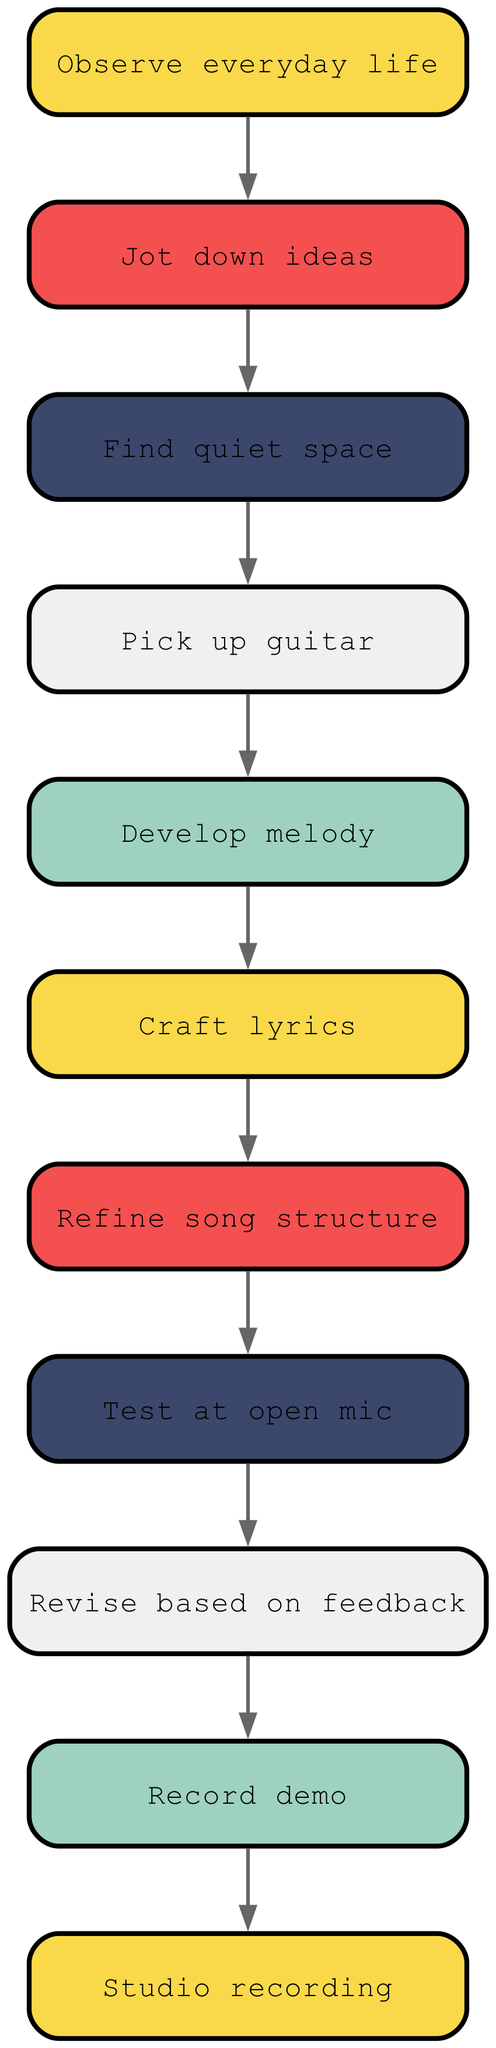What is the first step in the songwriting process? The diagram indicates that the first step in John Prine's songwriting process is to "Observe everyday life." This is the initial node before any other actions are taken.
Answer: Observe everyday life How many nodes are in the diagram? By counting all the unique processes involved in the diagram, we find there are 11 distinct nodes representing different steps in the songwriting process.
Answer: 11 What is the last step before "Studio recording"? The edge connecting "Record demo" to "Studio recording" shows that the last step before asserting a studio recording is the creation of a demo.
Answer: Record demo What is the relationship between "Revise based on feedback" and "Test at open mic"? The diagram shows a directed edge from "Test at open mic" leading to "Revise based on feedback," indicating that feedback gathered from testing the song live is used for revising the song accordingly.
Answer: Revise based on feedback Which step follows "Craft lyrics"? The flow directed from "Craft lyrics" leads to "Refine song structure," meaning this step occurs next in the process after writing the lyrics.
Answer: Refine song structure Name two steps that occur after finding a quiet space. After "Find quiet space," the diagram shows that the next steps are "Pick up guitar" and subsequently "Develop melody." Therefore, both of these steps come next in the process.
Answer: Pick up guitar, Develop melody What is the step immediately preceding "Record demo"? The directed edge from "Revise based on feedback" clearly indicates that this is the immediate step before moving on to the "Record demo."
Answer: Revise based on feedback Is there any step that occurs before "Develop melody"? If so, name it. Yes, according to the directed flow, "Pick up guitar" occurs immediately before "Develop melody," serving as a precursor to creating the melody itself.
Answer: Pick up guitar How many edges are present in the diagram? Each edge represents a connection between two nodes. Upon counting, there are 10 edges depicted in the songwriting process flow chart.
Answer: 10 